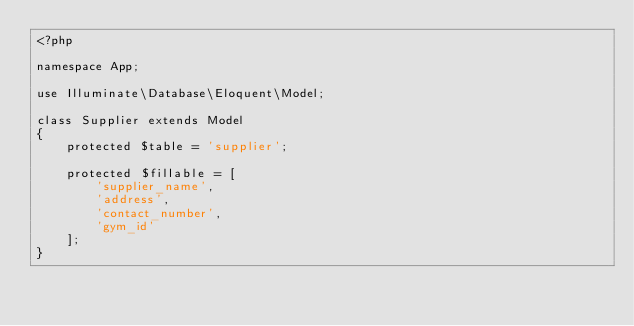Convert code to text. <code><loc_0><loc_0><loc_500><loc_500><_PHP_><?php

namespace App;

use Illuminate\Database\Eloquent\Model;

class Supplier extends Model
{
    protected $table = 'supplier';

    protected $fillable = [
        'supplier_name',
        'address',
        'contact_number',
        'gym_id'
    ];
}
</code> 